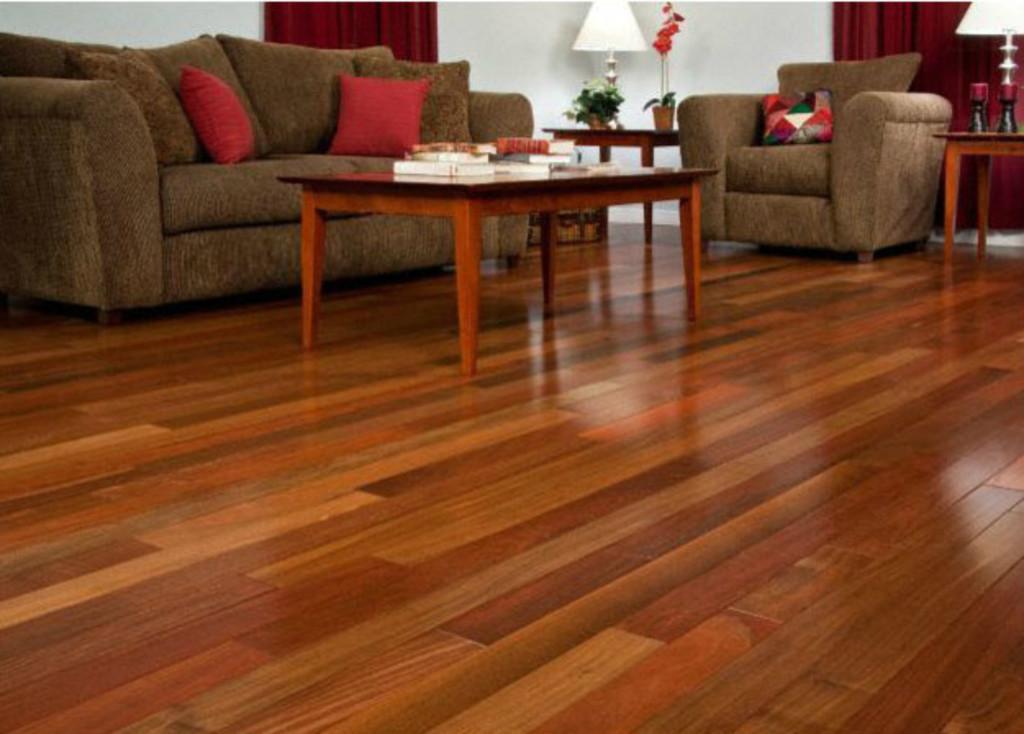In one or two sentences, can you explain what this image depicts? In this image i can see a table couch,lamp,flower vase. 